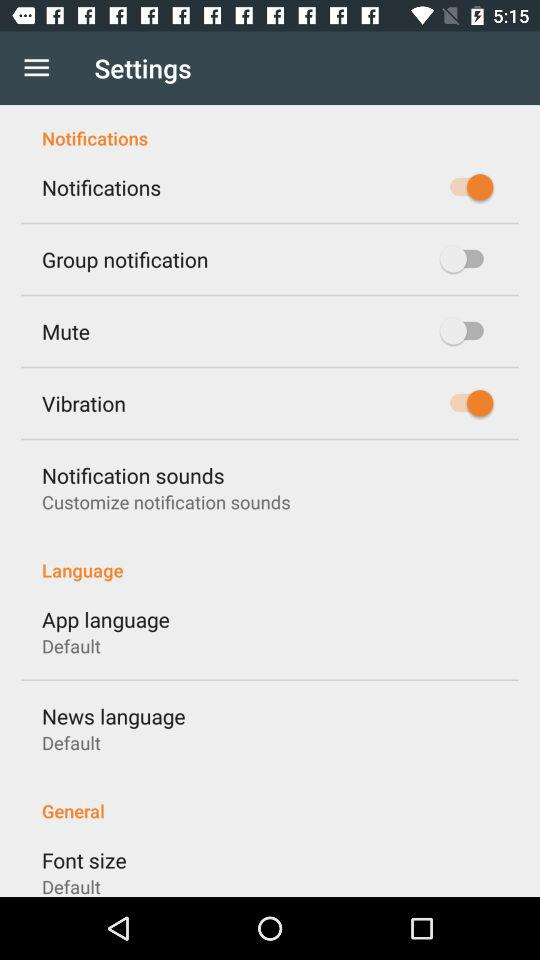What is the status of the news language? The status is default. 